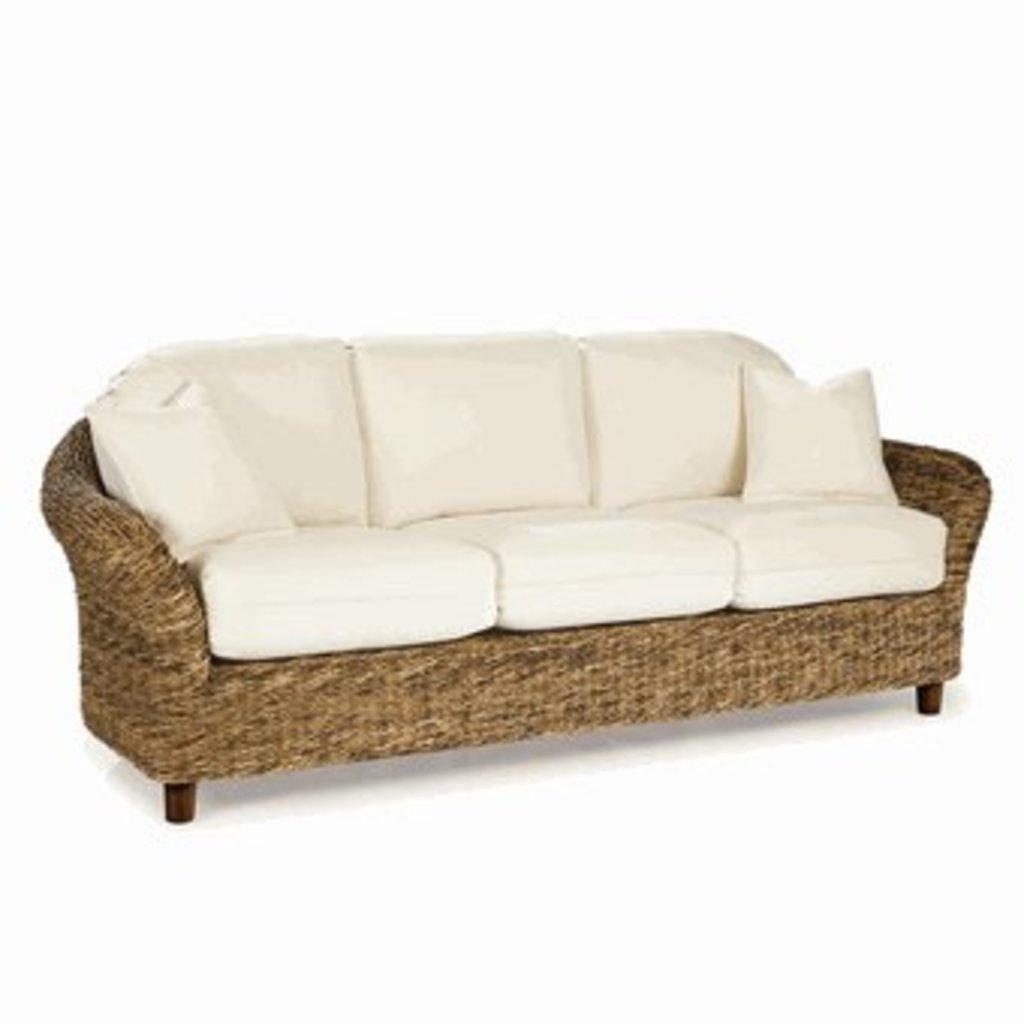Describe this image in one or two sentences. In this picture, we see sea grass sleeper sofa. On the sofa, we see two white cushions. In the background, it is white in color. 